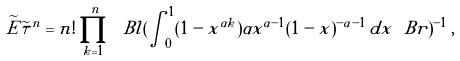Convert formula to latex. <formula><loc_0><loc_0><loc_500><loc_500>\widetilde { E } \widetilde { \tau } ^ { n } = n ! \prod _ { k = 1 } ^ { n } \ B l ( \int _ { 0 } ^ { 1 } ( 1 - x ^ { \alpha k } ) \alpha x ^ { \alpha - 1 } ( 1 - x ) ^ { - \alpha - 1 } \, d x \ B r ) ^ { - 1 } \, ,</formula> 